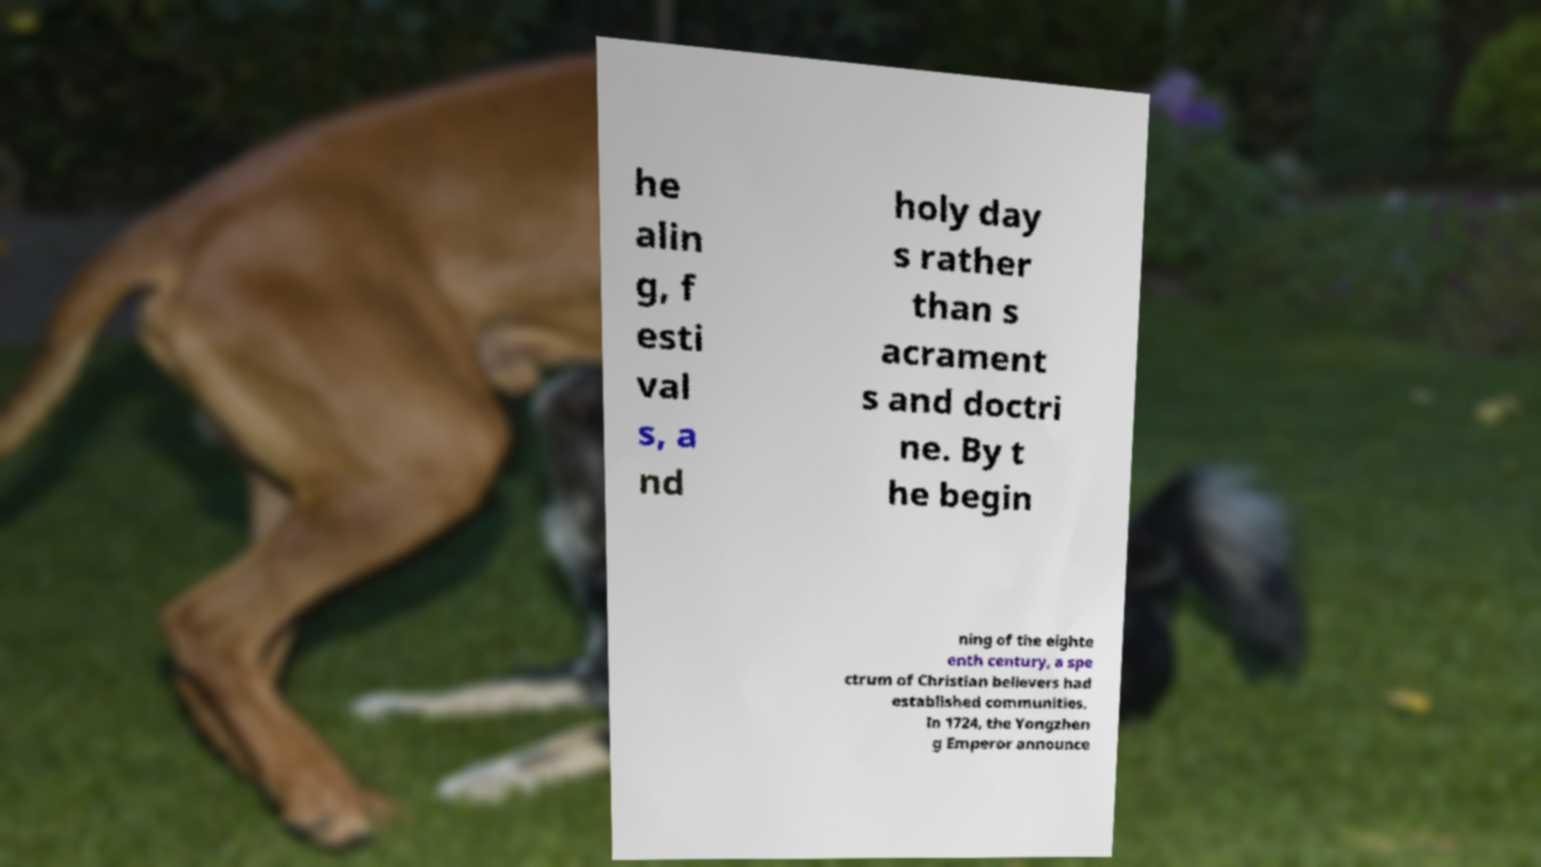Please read and relay the text visible in this image. What does it say? he alin g, f esti val s, a nd holy day s rather than s acrament s and doctri ne. By t he begin ning of the eighte enth century, a spe ctrum of Christian believers had established communities. In 1724, the Yongzhen g Emperor announce 